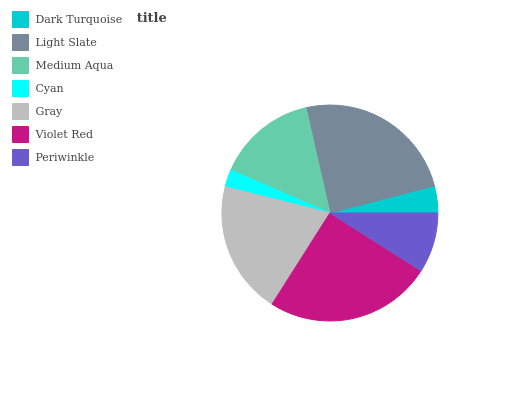Is Cyan the minimum?
Answer yes or no. Yes. Is Violet Red the maximum?
Answer yes or no. Yes. Is Light Slate the minimum?
Answer yes or no. No. Is Light Slate the maximum?
Answer yes or no. No. Is Light Slate greater than Dark Turquoise?
Answer yes or no. Yes. Is Dark Turquoise less than Light Slate?
Answer yes or no. Yes. Is Dark Turquoise greater than Light Slate?
Answer yes or no. No. Is Light Slate less than Dark Turquoise?
Answer yes or no. No. Is Medium Aqua the high median?
Answer yes or no. Yes. Is Medium Aqua the low median?
Answer yes or no. Yes. Is Periwinkle the high median?
Answer yes or no. No. Is Dark Turquoise the low median?
Answer yes or no. No. 